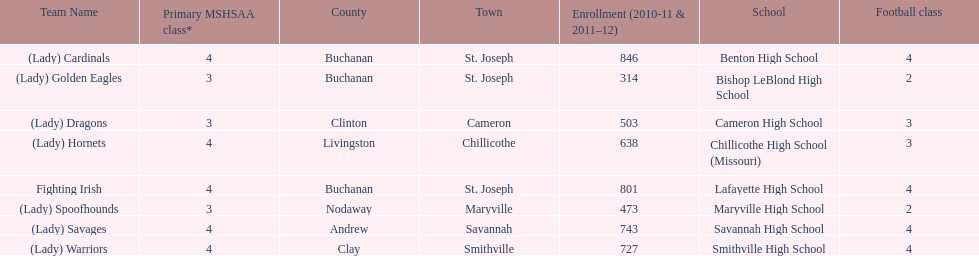How many are enrolled at each school? Benton High School, 846, Bishop LeBlond High School, 314, Cameron High School, 503, Chillicothe High School (Missouri), 638, Lafayette High School, 801, Maryville High School, 473, Savannah High School, 743, Smithville High School, 727. Which school has at only three football classes? Cameron High School, 3, Chillicothe High School (Missouri), 3. Which school has 638 enrolled and 3 football classes? Chillicothe High School (Missouri). 